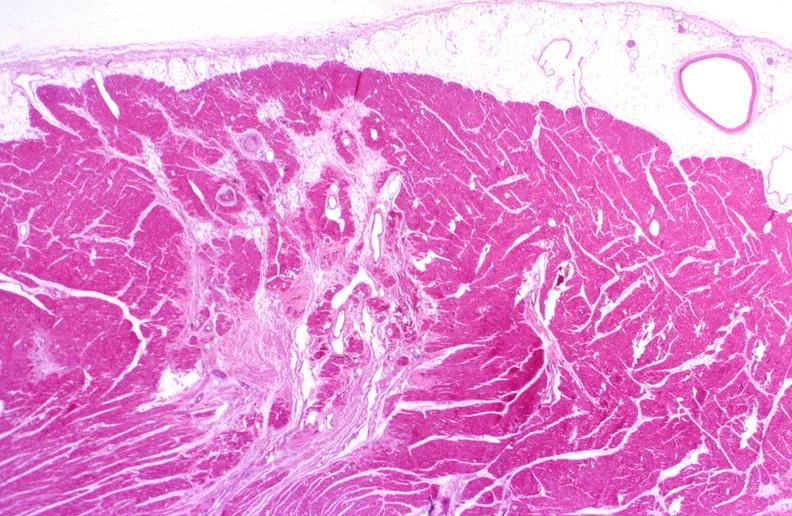what does this image show?
Answer the question using a single word or phrase. Heart 